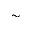<formula> <loc_0><loc_0><loc_500><loc_500>\sim</formula> 